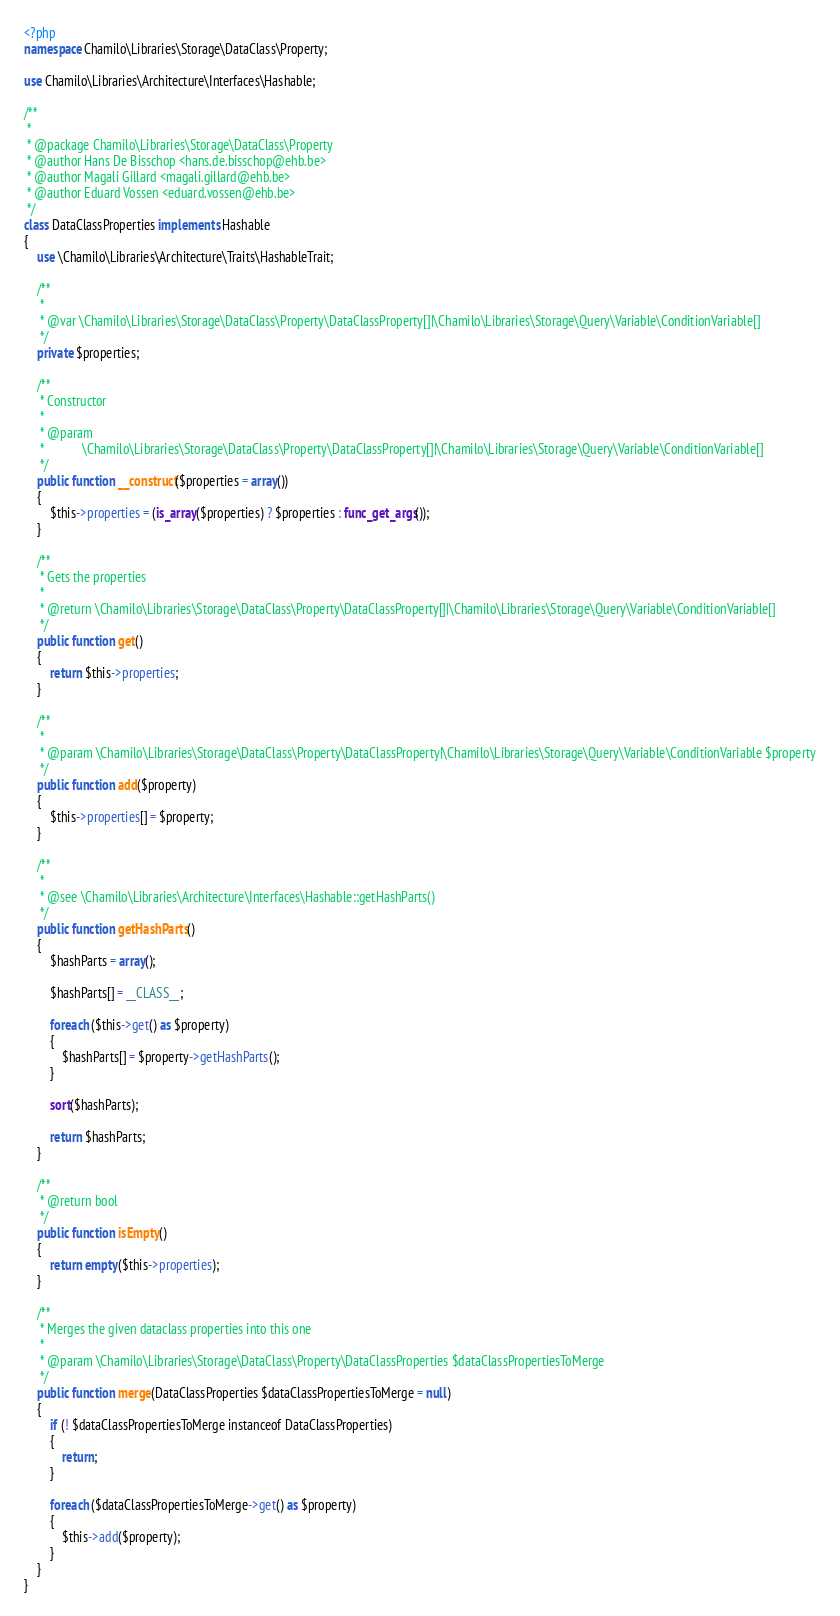Convert code to text. <code><loc_0><loc_0><loc_500><loc_500><_PHP_><?php
namespace Chamilo\Libraries\Storage\DataClass\Property;

use Chamilo\Libraries\Architecture\Interfaces\Hashable;

/**
 *
 * @package Chamilo\Libraries\Storage\DataClass\Property
 * @author Hans De Bisschop <hans.de.bisschop@ehb.be>
 * @author Magali Gillard <magali.gillard@ehb.be>
 * @author Eduard Vossen <eduard.vossen@ehb.be>
 */
class DataClassProperties implements Hashable
{
    use \Chamilo\Libraries\Architecture\Traits\HashableTrait;

    /**
     *
     * @var \Chamilo\Libraries\Storage\DataClass\Property\DataClassProperty[]|\Chamilo\Libraries\Storage\Query\Variable\ConditionVariable[]
     */
    private $properties;

    /**
     * Constructor
     *
     * @param
     *            \Chamilo\Libraries\Storage\DataClass\Property\DataClassProperty[]|\Chamilo\Libraries\Storage\Query\Variable\ConditionVariable[]
     */
    public function __construct($properties = array())
    {
        $this->properties = (is_array($properties) ? $properties : func_get_args());
    }

    /**
     * Gets the properties
     *
     * @return \Chamilo\Libraries\Storage\DataClass\Property\DataClassProperty[]|\Chamilo\Libraries\Storage\Query\Variable\ConditionVariable[]
     */
    public function get()
    {
        return $this->properties;
    }

    /**
     *
     * @param \Chamilo\Libraries\Storage\DataClass\Property\DataClassProperty|\Chamilo\Libraries\Storage\Query\Variable\ConditionVariable $property
     */
    public function add($property)
    {
        $this->properties[] = $property;
    }

    /**
     *
     * @see \Chamilo\Libraries\Architecture\Interfaces\Hashable::getHashParts()
     */
    public function getHashParts()
    {
        $hashParts = array();

        $hashParts[] = __CLASS__;

        foreach ($this->get() as $property)
        {
            $hashParts[] = $property->getHashParts();
        }

        sort($hashParts);

        return $hashParts;
    }

    /**
     * @return bool
     */
    public function isEmpty()
    {
        return empty($this->properties);
    }

    /**
     * Merges the given dataclass properties into this one
     *
     * @param \Chamilo\Libraries\Storage\DataClass\Property\DataClassProperties $dataClassPropertiesToMerge
     */
    public function merge(DataClassProperties $dataClassPropertiesToMerge = null)
    {
        if (! $dataClassPropertiesToMerge instanceof DataClassProperties)
        {
            return;
        }

        foreach ($dataClassPropertiesToMerge->get() as $property)
        {
            $this->add($property);
        }
    }
}
</code> 